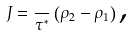<formula> <loc_0><loc_0><loc_500><loc_500>J = \frac { } { \tau ^ { \ast } } \left ( \rho _ { 2 } - \rho _ { 1 } \right ) \text {,}</formula> 